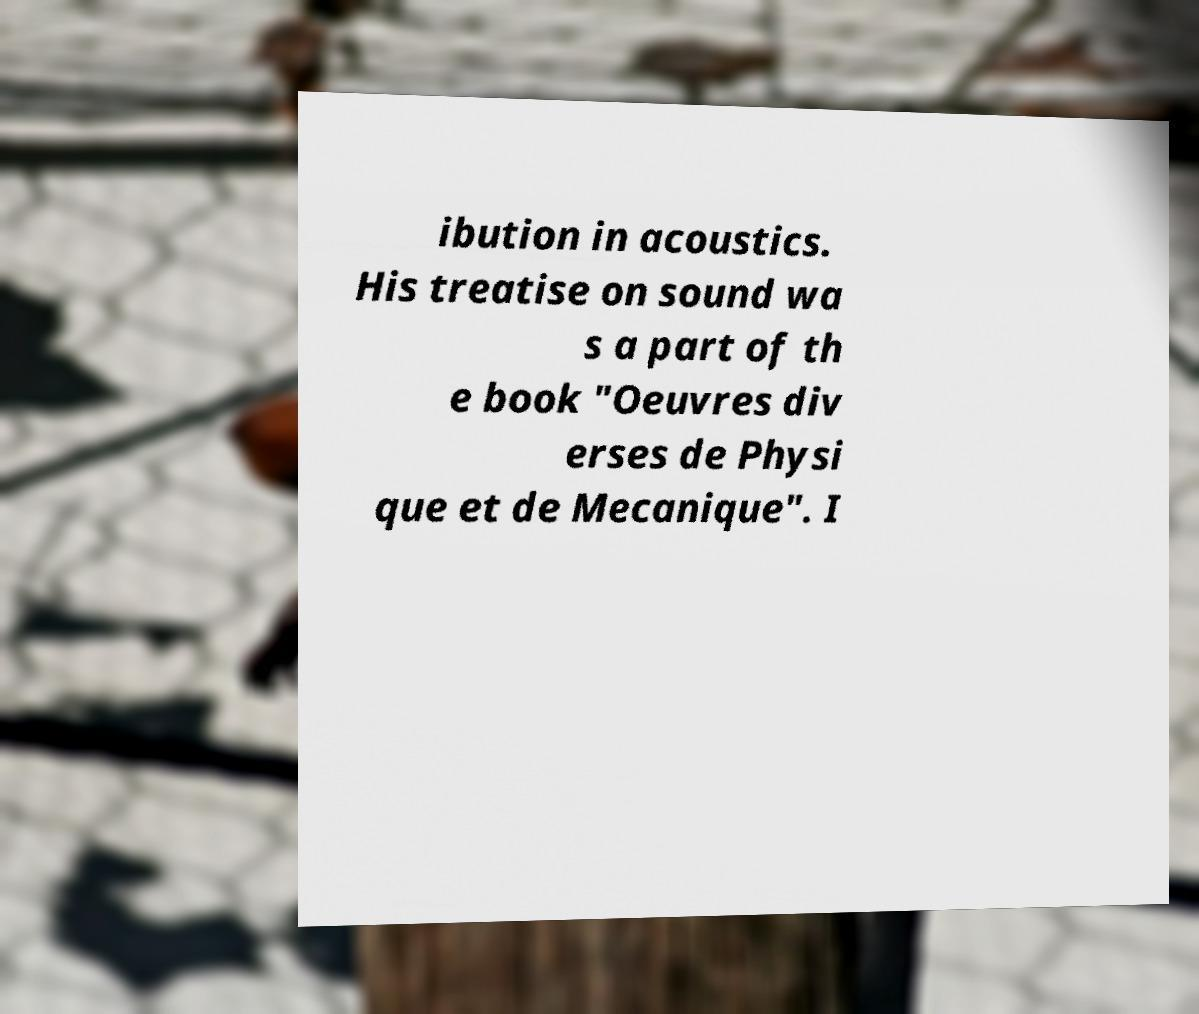Please identify and transcribe the text found in this image. ibution in acoustics. His treatise on sound wa s a part of th e book "Oeuvres div erses de Physi que et de Mecanique". I 